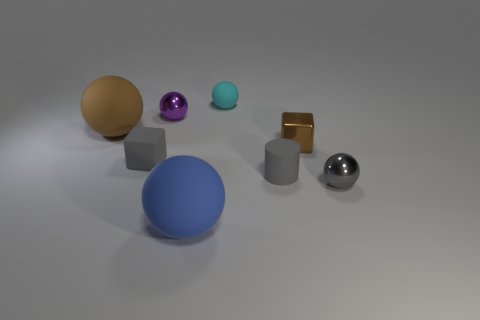Subtract 3 spheres. How many spheres are left? 2 Subtract all blue spheres. How many spheres are left? 4 Add 2 cylinders. How many objects exist? 10 Subtract all big spheres. How many spheres are left? 3 Subtract all yellow spheres. Subtract all yellow cylinders. How many spheres are left? 5 Add 8 small gray metal balls. How many small gray metal balls exist? 9 Subtract 0 blue cylinders. How many objects are left? 8 Subtract all cylinders. How many objects are left? 7 Subtract all cyan rubber objects. Subtract all small cylinders. How many objects are left? 6 Add 5 cylinders. How many cylinders are left? 6 